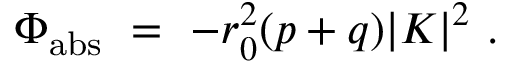Convert formula to latex. <formula><loc_0><loc_0><loc_500><loc_500>\Phi _ { a b s } = - r _ { 0 } ^ { 2 } ( p + q ) | K | ^ { 2 } .</formula> 